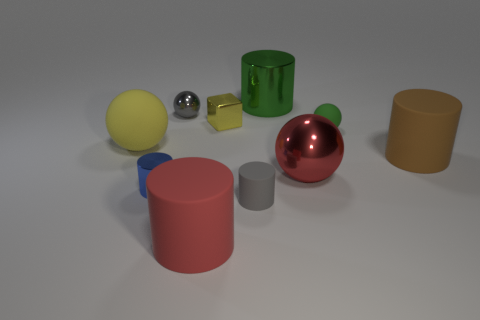What is the color of the tiny matte sphere?
Your response must be concise. Green. How many tiny rubber spheres have the same color as the metal block?
Offer a very short reply. 0. There is a yellow matte ball; are there any red metal objects to the left of it?
Provide a succinct answer. No. Are there the same number of brown cylinders behind the small block and blocks in front of the red ball?
Make the answer very short. Yes. Does the gray object that is in front of the large brown rubber cylinder have the same size as the metal ball that is in front of the yellow cube?
Provide a short and direct response. No. There is a yellow object on the right side of the shiny ball behind the matte ball that is left of the tiny green thing; what is its shape?
Make the answer very short. Cube. Is there any other thing that is the same material as the blue thing?
Give a very brief answer. Yes. What size is the red shiny object that is the same shape as the large yellow rubber thing?
Keep it short and to the point. Large. There is a thing that is both in front of the large brown object and on the left side of the large red rubber cylinder; what is its color?
Give a very brief answer. Blue. Are the brown object and the big red object on the right side of the big metallic cylinder made of the same material?
Offer a very short reply. No. 